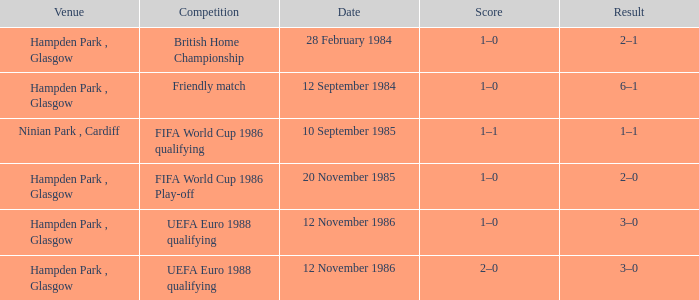What is the Score of the Fifa World Cup 1986 Qualifying Competition? 1–1. 